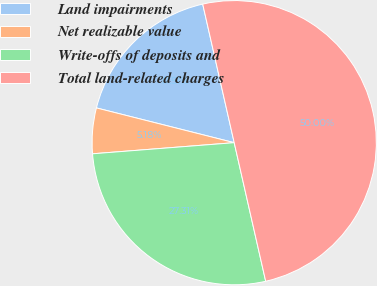<chart> <loc_0><loc_0><loc_500><loc_500><pie_chart><fcel>Land impairments<fcel>Net realizable value<fcel>Write-offs of deposits and<fcel>Total land-related charges<nl><fcel>17.51%<fcel>5.18%<fcel>27.31%<fcel>50.0%<nl></chart> 